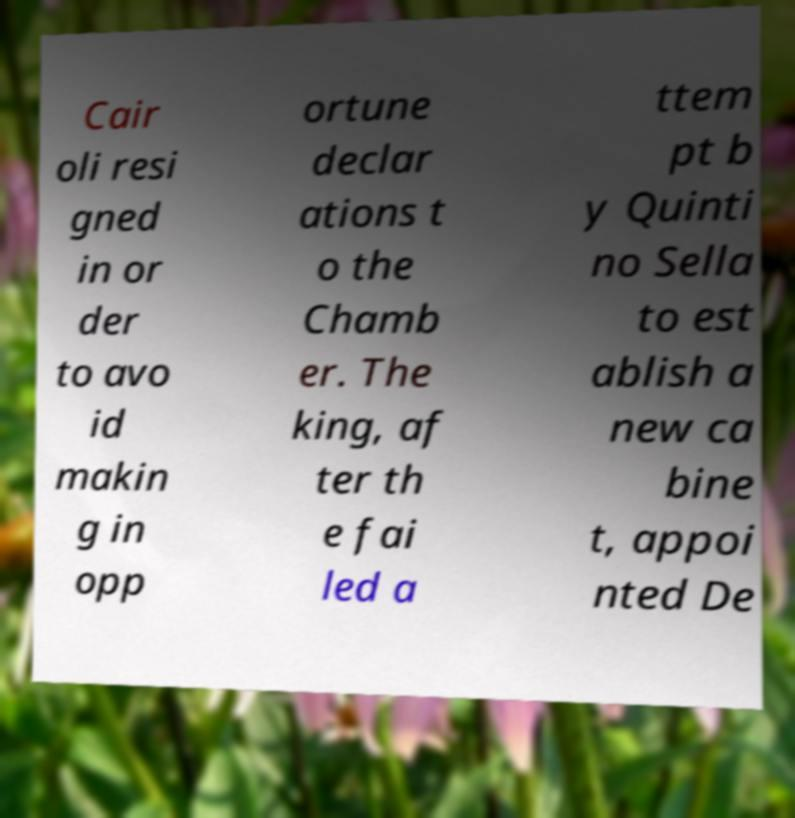Can you accurately transcribe the text from the provided image for me? Cair oli resi gned in or der to avo id makin g in opp ortune declar ations t o the Chamb er. The king, af ter th e fai led a ttem pt b y Quinti no Sella to est ablish a new ca bine t, appoi nted De 